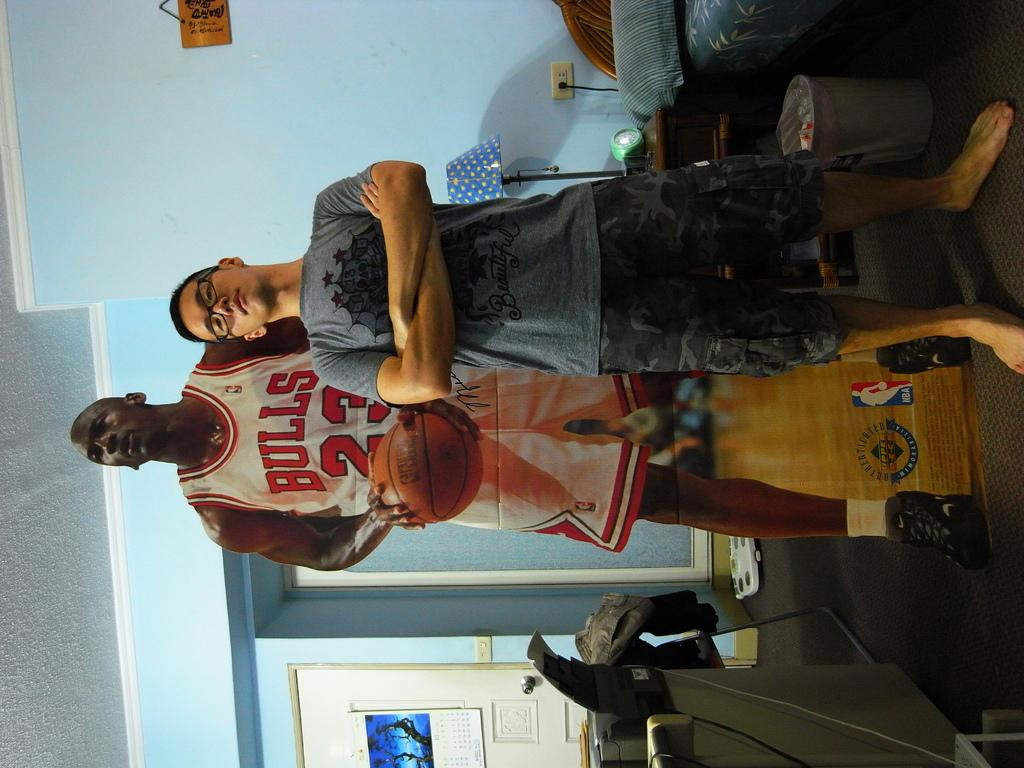Provide a one-sentence caption for the provided image. the man wearing Bulls 23 jersey is holding the ball. 